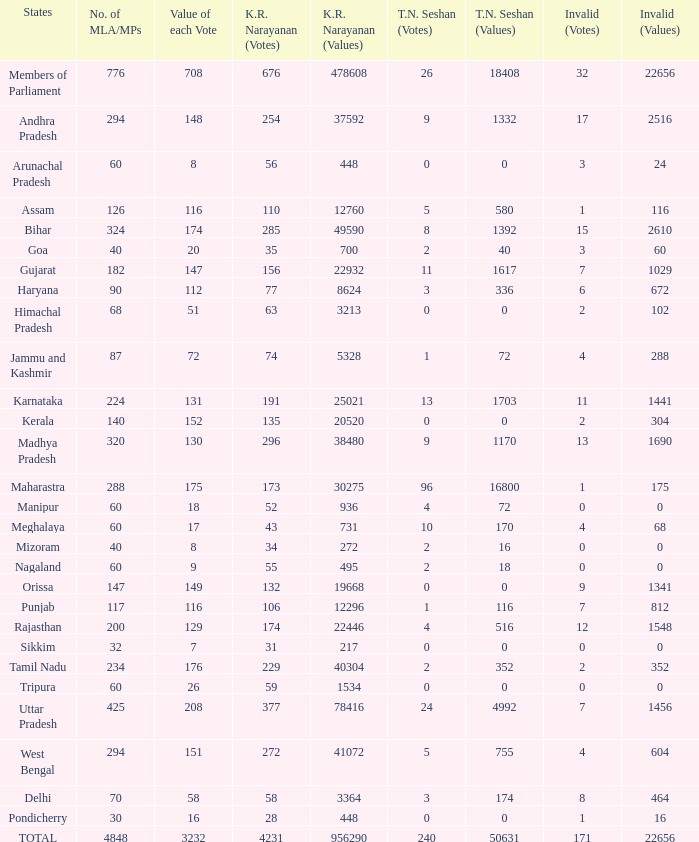What are the k. r. narayanan values associated with pondicherry? 448.0. 